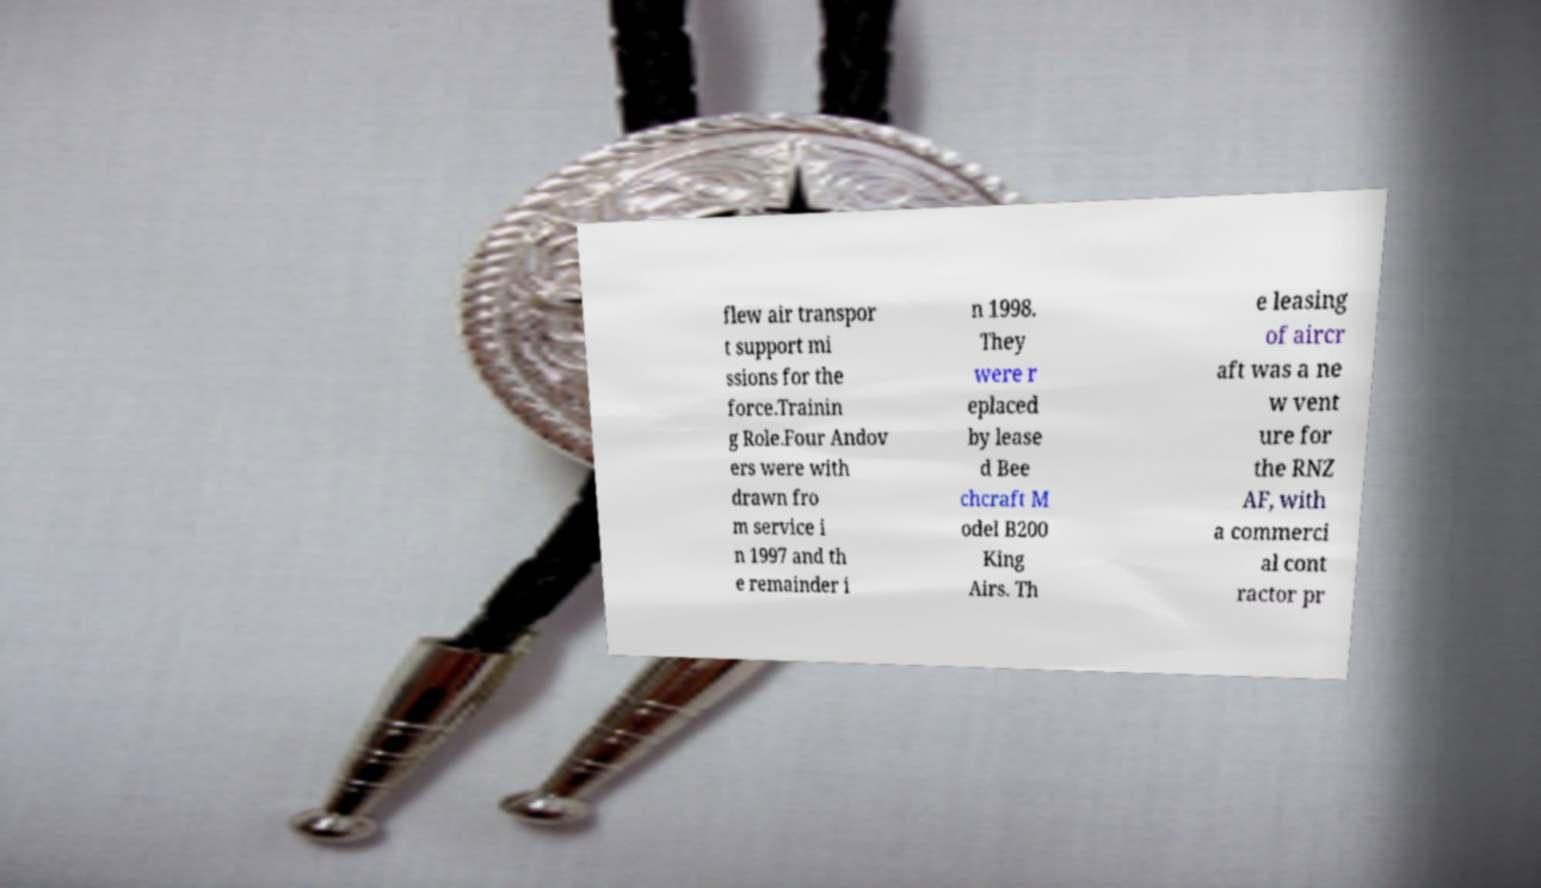I need the written content from this picture converted into text. Can you do that? flew air transpor t support mi ssions for the force.Trainin g Role.Four Andov ers were with drawn fro m service i n 1997 and th e remainder i n 1998. They were r eplaced by lease d Bee chcraft M odel B200 King Airs. Th e leasing of aircr aft was a ne w vent ure for the RNZ AF, with a commerci al cont ractor pr 